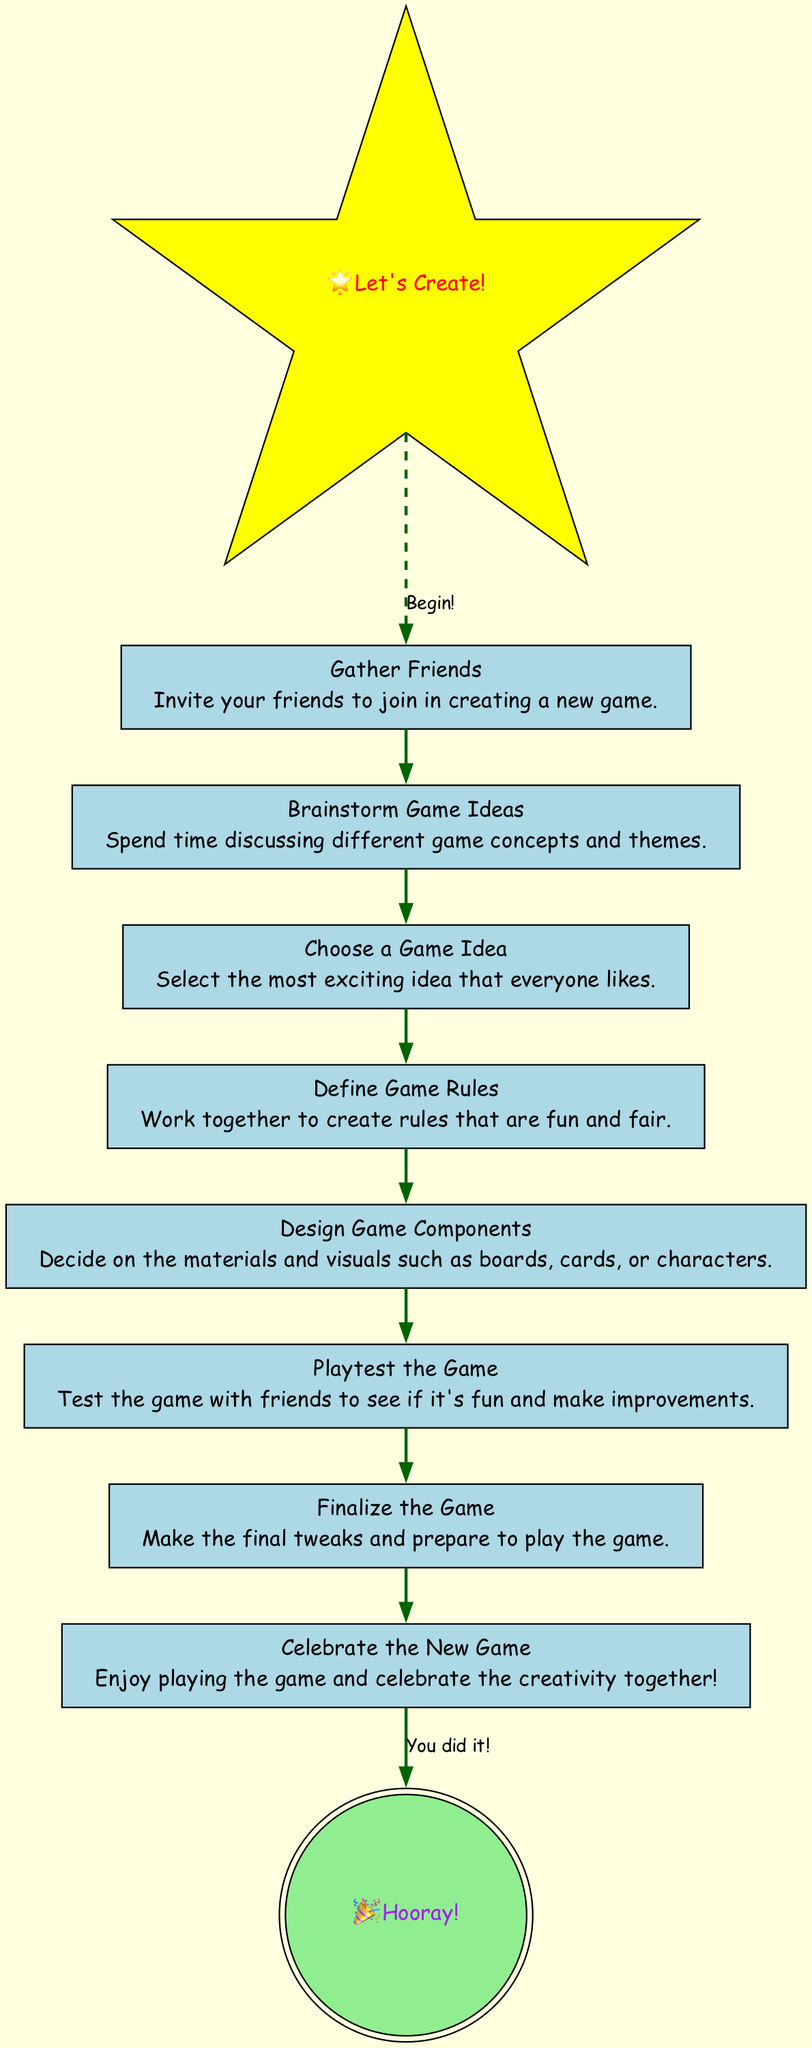What is the first step in creating a new game? The first step is labeled "Gather Friends" in the diagram, which indicates that inviting friends is essential for starting the game creation process.
Answer: Gather Friends How many steps are there in total? By counting each labeled node in the diagram, there are eight steps depicted, starting with "Gather Friends" and ending with "Celebrate the New Game."
Answer: Eight What do you do after choosing a game idea? After choosing a game idea, the next step is to "Define Game Rules," which involves collaboratively creating rules for the game.
Answer: Define Game Rules Which step comes just before the celebration? The step that comes just before the celebration is "Finalize the Game," where final tweaks are made before enjoying the game with friends.
Answer: Finalize the Game Are there any playful elements in the diagram? Yes, there are playful elements represented by a star-shaped node that says "Let's Create!" and a double-circle node that says "Hooray!" indicating a fun and celebratory theme throughout the flow of the chart.
Answer: Yes What two nodes are connected with a dashed edge? The dashed edge connects "Let's Create!" to "Gather Friends," indicating a playful beginning to the process of creating a new game with friends.
Answer: Let's Create! and Gather Friends What is the purpose of the "Playtest the Game" step? The purpose of the "Playtest the Game" step is to test the game to see if it’s fun and make any improvements needed based on everyone's feedback.
Answer: To test the game and improve it What color is used for the final step in the diagram? The final step "Celebrate the New Game" is represented in light green color, which reflects a sense of achievement and positivity associated with completing the game creation process.
Answer: Light green 